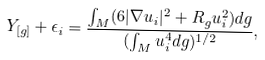<formula> <loc_0><loc_0><loc_500><loc_500>Y _ { [ g ] } + \epsilon _ { i } = \frac { \int _ { M } ( 6 | \nabla u _ { i } | ^ { 2 } + R _ { g } u ^ { 2 } _ { i } ) d g } { ( \int _ { M } u ^ { 4 } _ { i } d g ) ^ { 1 / 2 } } ,</formula> 